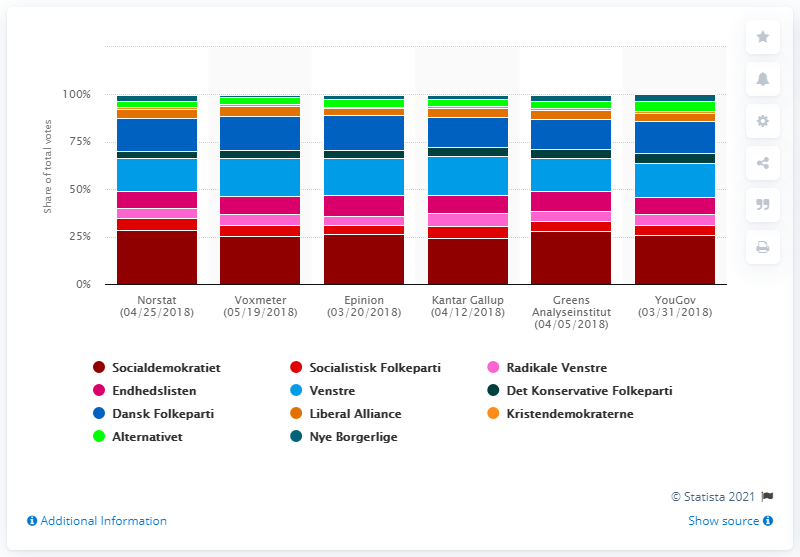Draw attention to some important aspects in this diagram. According to Norstat, Socialdemokraterne would have received 28.6% of the total votes. 